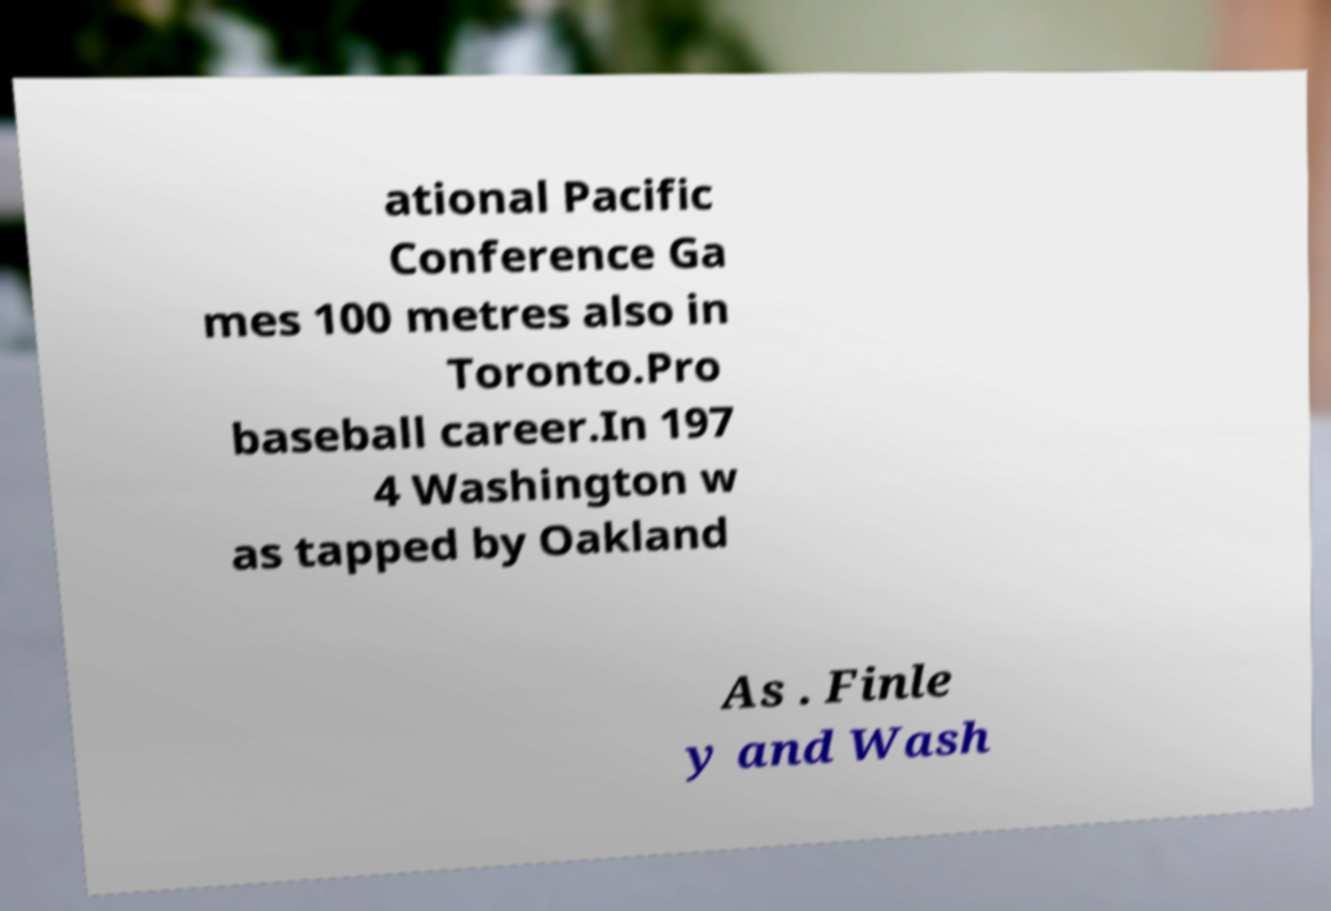Can you accurately transcribe the text from the provided image for me? ational Pacific Conference Ga mes 100 metres also in Toronto.Pro baseball career.In 197 4 Washington w as tapped by Oakland As . Finle y and Wash 